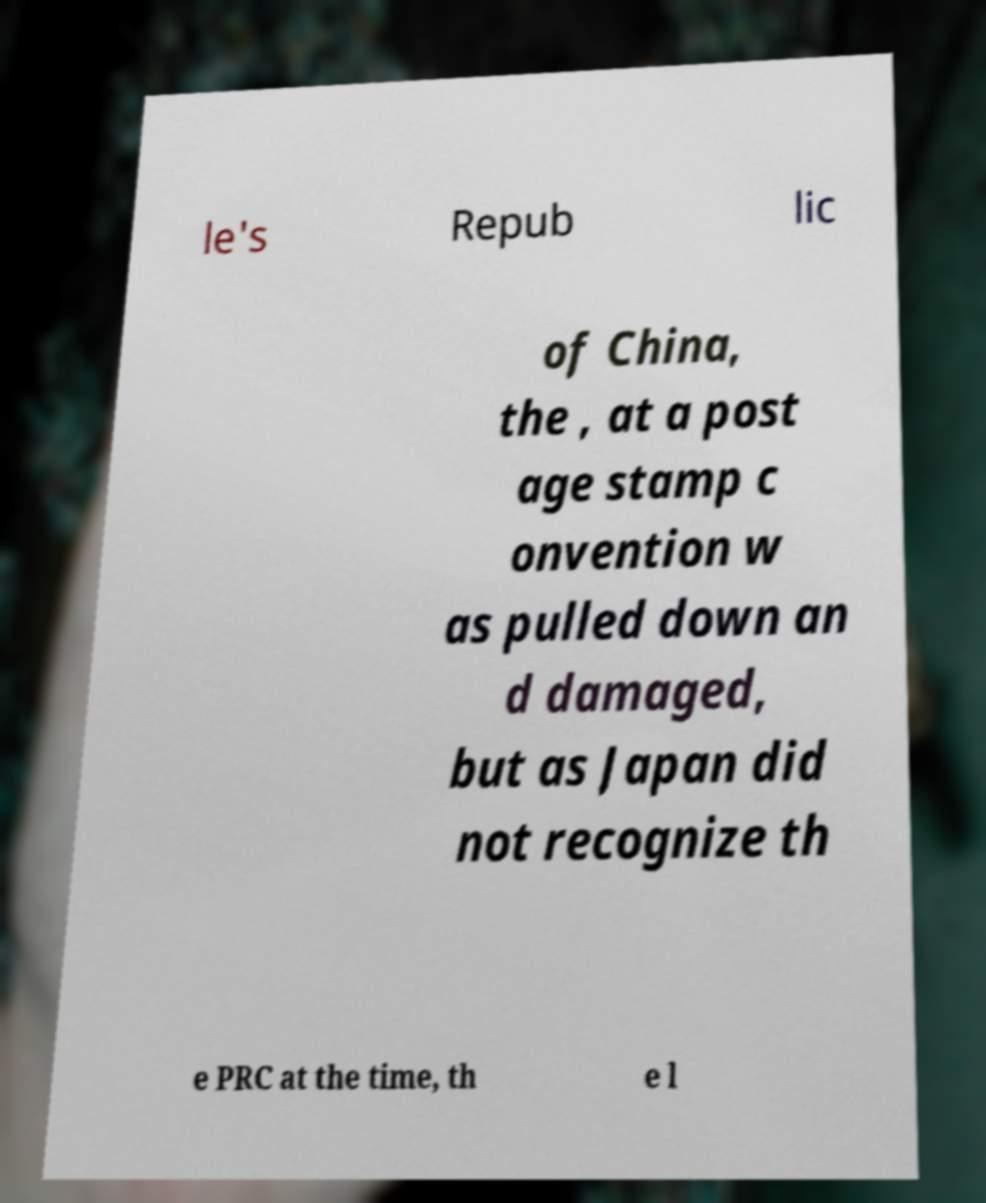Can you read and provide the text displayed in the image?This photo seems to have some interesting text. Can you extract and type it out for me? le's Repub lic of China, the , at a post age stamp c onvention w as pulled down an d damaged, but as Japan did not recognize th e PRC at the time, th e l 